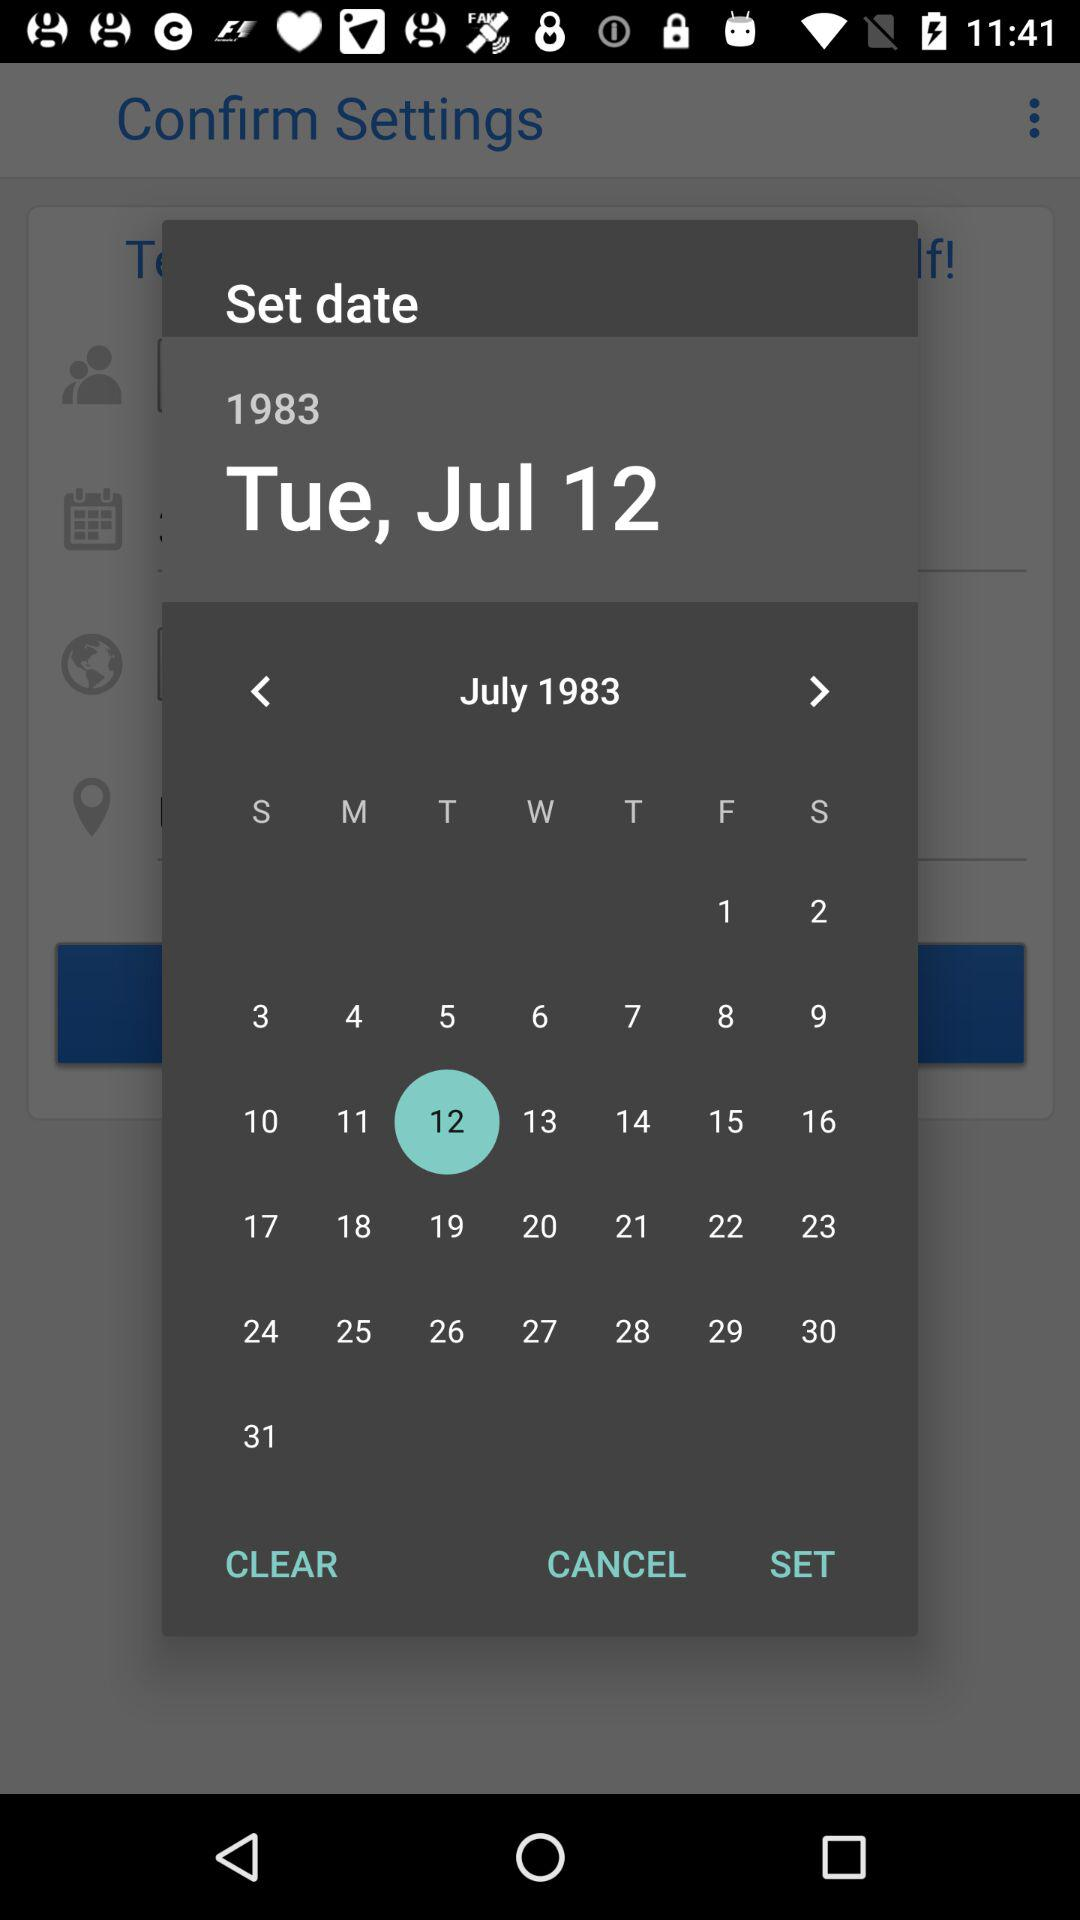What day is it on July 12? The day is Tuesday. 